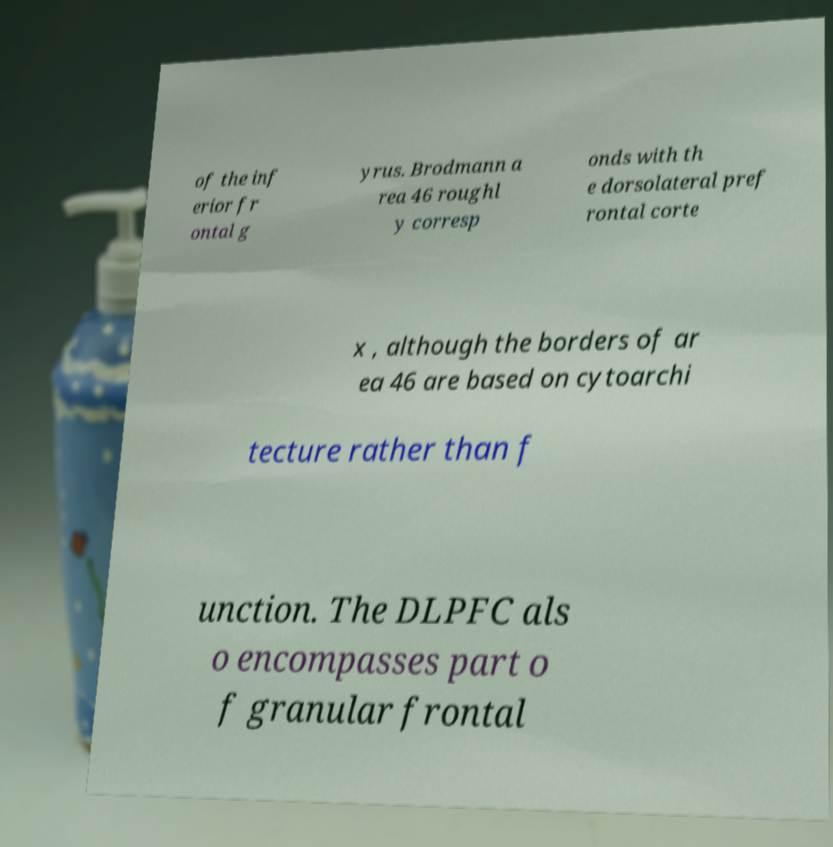Could you assist in decoding the text presented in this image and type it out clearly? of the inf erior fr ontal g yrus. Brodmann a rea 46 roughl y corresp onds with th e dorsolateral pref rontal corte x , although the borders of ar ea 46 are based on cytoarchi tecture rather than f unction. The DLPFC als o encompasses part o f granular frontal 